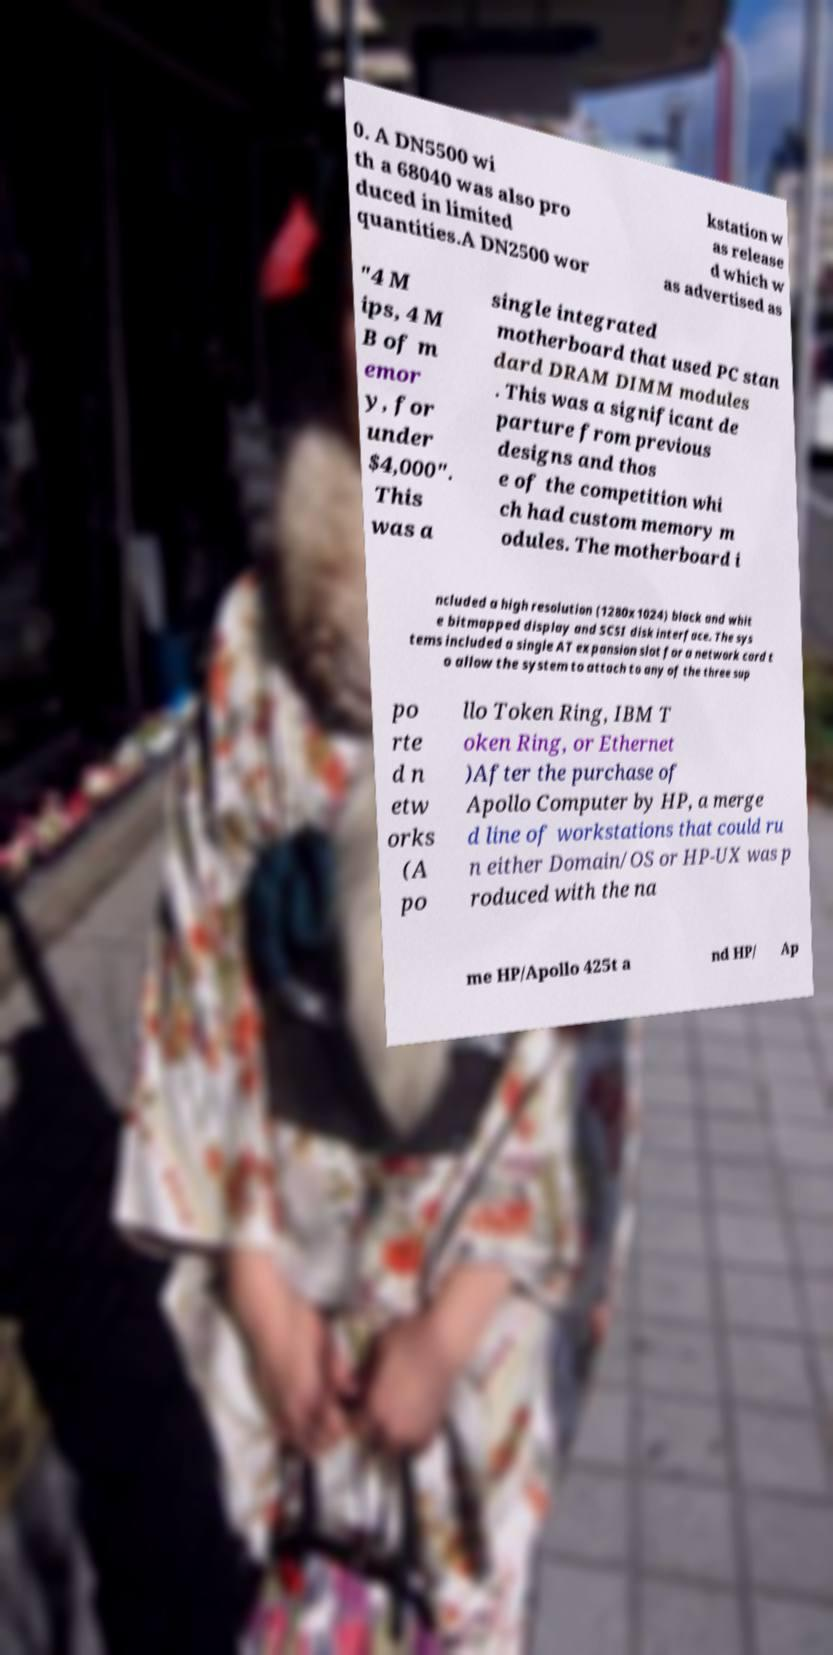Could you assist in decoding the text presented in this image and type it out clearly? 0. A DN5500 wi th a 68040 was also pro duced in limited quantities.A DN2500 wor kstation w as release d which w as advertised as "4 M ips, 4 M B of m emor y, for under $4,000". This was a single integrated motherboard that used PC stan dard DRAM DIMM modules . This was a significant de parture from previous designs and thos e of the competition whi ch had custom memory m odules. The motherboard i ncluded a high resolution (1280x1024) black and whit e bitmapped display and SCSI disk interface. The sys tems included a single AT expansion slot for a network card t o allow the system to attach to any of the three sup po rte d n etw orks (A po llo Token Ring, IBM T oken Ring, or Ethernet )After the purchase of Apollo Computer by HP, a merge d line of workstations that could ru n either Domain/OS or HP-UX was p roduced with the na me HP/Apollo 425t a nd HP/ Ap 